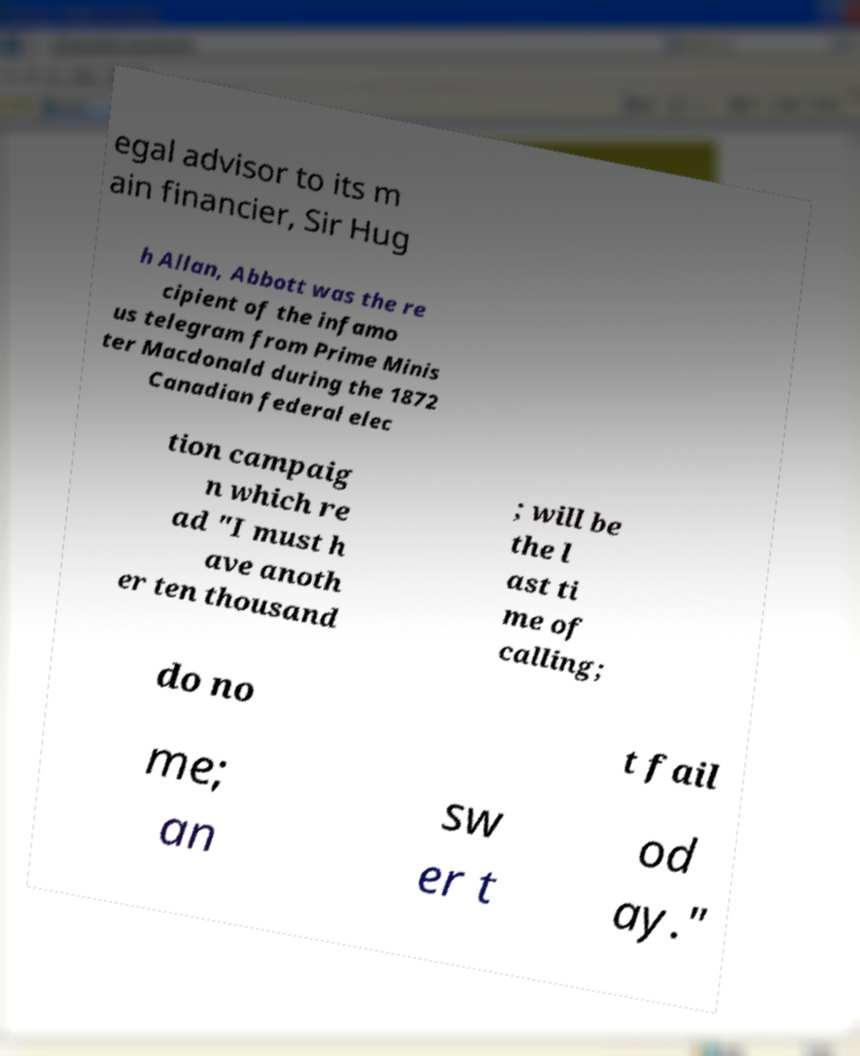Please identify and transcribe the text found in this image. egal advisor to its m ain financier, Sir Hug h Allan, Abbott was the re cipient of the infamo us telegram from Prime Minis ter Macdonald during the 1872 Canadian federal elec tion campaig n which re ad "I must h ave anoth er ten thousand ; will be the l ast ti me of calling; do no t fail me; an sw er t od ay." 